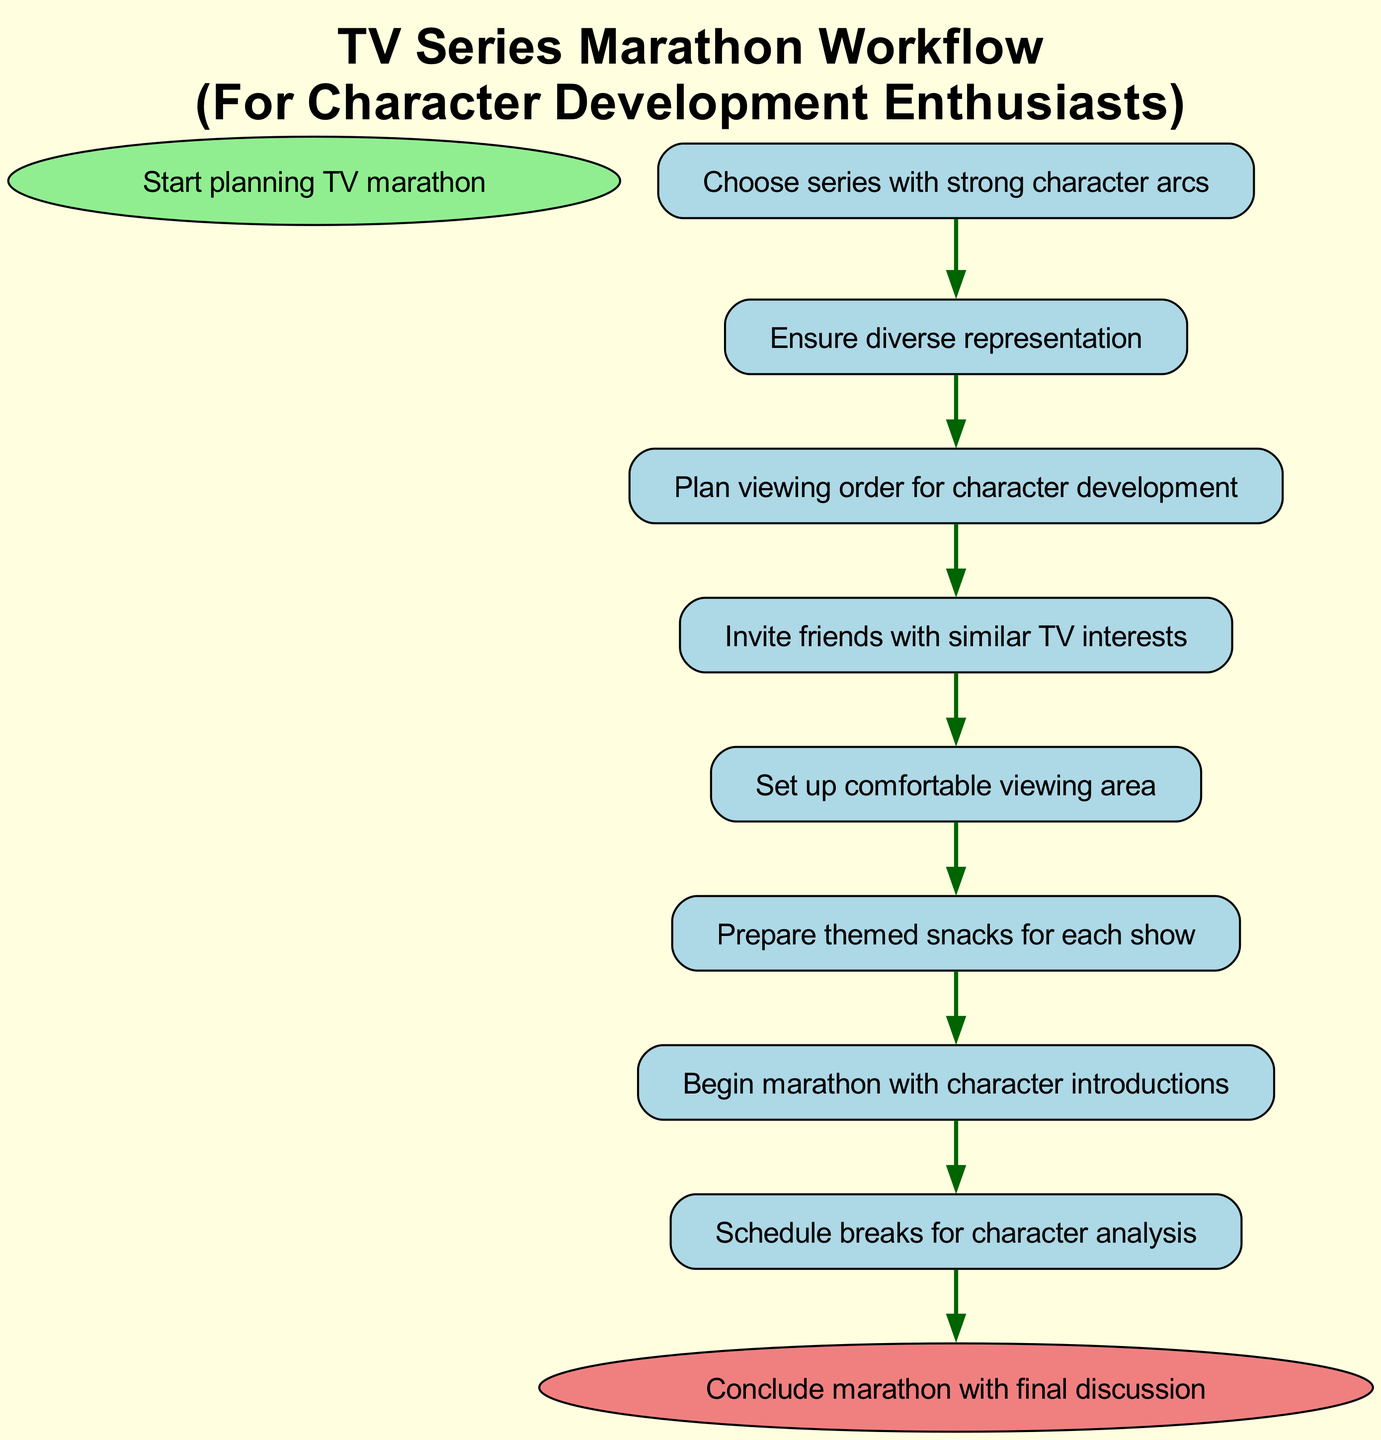What is the first step in the workflow? The first step in the workflow is indicated by the start node, which states "Start planning TV marathon."
Answer: Start planning TV marathon How many nodes are in the diagram? The diagram contains 10 nodes, including the start and end nodes. Each unique step in the workflow is represented as a separate node.
Answer: 10 What does the last node represent? The last node in the workflow is labeled "Conclude marathon with final discussion," showing the final step of the process.
Answer: Conclude marathon with final discussion Which node comes after "Prepare themed snacks for each show"? After this node, "Start marathon with character introductions" follows, indicating that the marathon will begin once the snacks are ready.
Answer: Start marathon with character introductions What is the main focus of the selected series according to the workflow? The workflow emphasizes "strong character arcs," indicating that the series chosen should have a significant focus on character development.
Answer: Strong character arcs How does one proceed from inviting friends to preparing the space? Once friends with similar TV interests are invited, the next step is to "Set up comfortable viewing area," signifying the preparation of the space for the marathon.
Answer: Set up comfortable viewing area What is the purpose of scheduling breaks in the workflow? The breaks are scheduled specifically for "character analysis," allowing the viewers to discuss and analyze character development throughout the marathon.
Answer: Character analysis How many steps are there before the marathon begins? There are six steps leading up to the start of the marathon: starting planning, selecting the series, checking representation, creating a schedule, inviting friends, and preparing space.
Answer: Six steps What is the thematic element incorporated in the snacks? The snacks are prepared to be "themed" for each show, which adds a fun and engaging element to the viewing experience centered on the shows being watched.
Answer: Themed snacks What happens after the final discussion is concluded? The flow chart does not indicate any further steps after the final discussion, signifying the end of the marathon planning process.
Answer: End of the process 